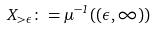<formula> <loc_0><loc_0><loc_500><loc_500>X _ { > \epsilon } \colon = \mu ^ { - 1 } ( ( \epsilon , \infty ) )</formula> 